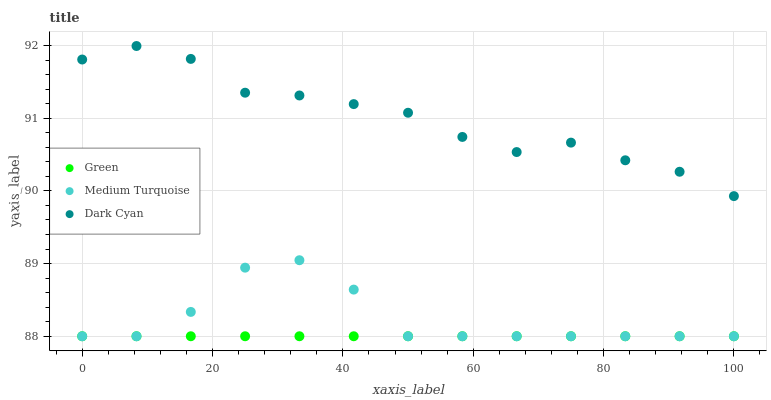Does Green have the minimum area under the curve?
Answer yes or no. Yes. Does Dark Cyan have the maximum area under the curve?
Answer yes or no. Yes. Does Medium Turquoise have the minimum area under the curve?
Answer yes or no. No. Does Medium Turquoise have the maximum area under the curve?
Answer yes or no. No. Is Green the smoothest?
Answer yes or no. Yes. Is Medium Turquoise the roughest?
Answer yes or no. Yes. Is Medium Turquoise the smoothest?
Answer yes or no. No. Is Green the roughest?
Answer yes or no. No. Does Green have the lowest value?
Answer yes or no. Yes. Does Dark Cyan have the highest value?
Answer yes or no. Yes. Does Medium Turquoise have the highest value?
Answer yes or no. No. Is Medium Turquoise less than Dark Cyan?
Answer yes or no. Yes. Is Dark Cyan greater than Medium Turquoise?
Answer yes or no. Yes. Does Green intersect Medium Turquoise?
Answer yes or no. Yes. Is Green less than Medium Turquoise?
Answer yes or no. No. Is Green greater than Medium Turquoise?
Answer yes or no. No. Does Medium Turquoise intersect Dark Cyan?
Answer yes or no. No. 